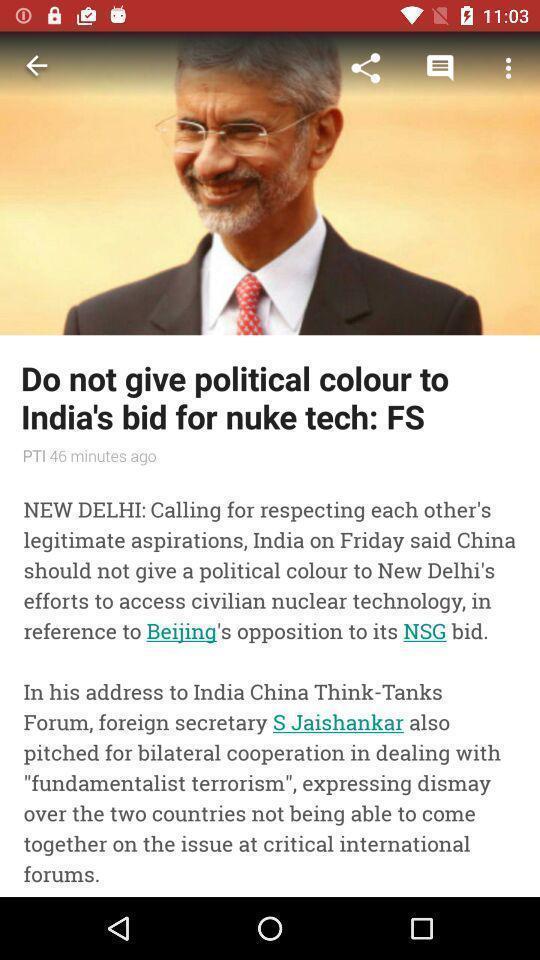Give me a summary of this screen capture. Screen displaying a political news. 